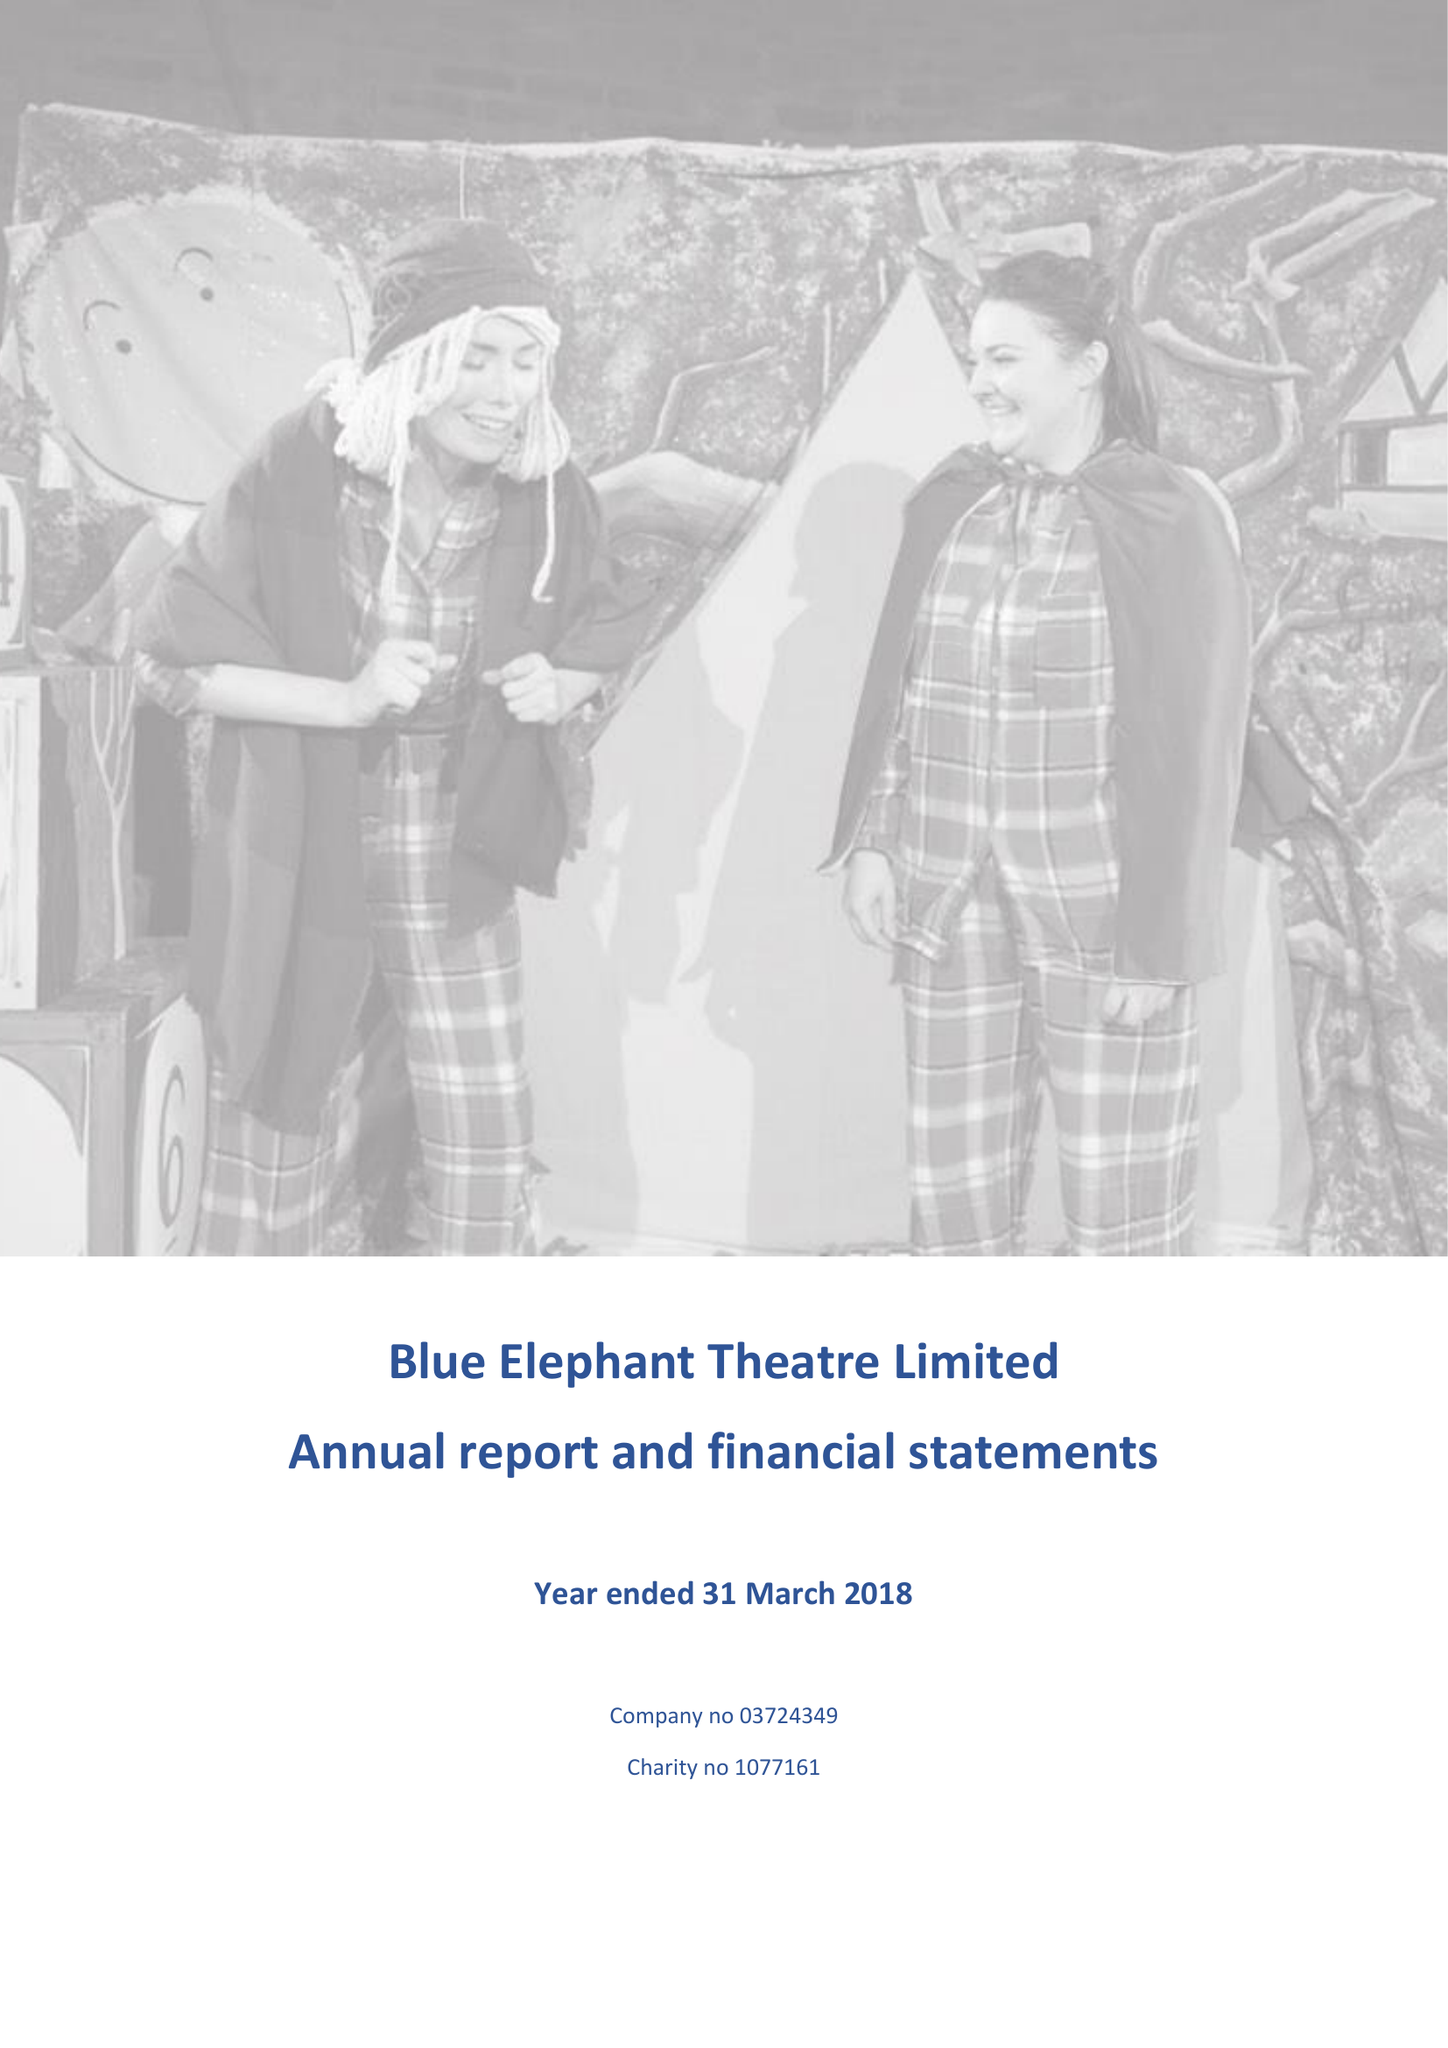What is the value for the charity_number?
Answer the question using a single word or phrase. 1077161 